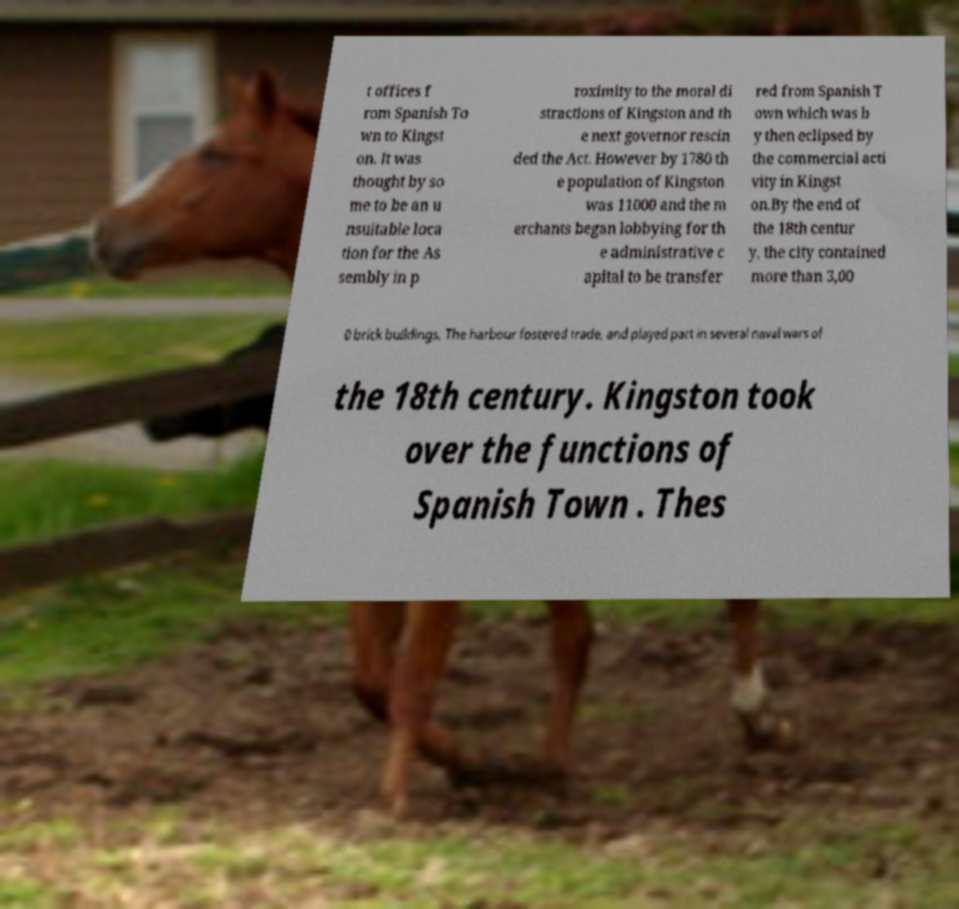For documentation purposes, I need the text within this image transcribed. Could you provide that? t offices f rom Spanish To wn to Kingst on. It was thought by so me to be an u nsuitable loca tion for the As sembly in p roximity to the moral di stractions of Kingston and th e next governor rescin ded the Act. However by 1780 th e population of Kingston was 11000 and the m erchants began lobbying for th e administrative c apital to be transfer red from Spanish T own which was b y then eclipsed by the commercial acti vity in Kingst on.By the end of the 18th centur y, the city contained more than 3,00 0 brick buildings. The harbour fostered trade, and played part in several naval wars of the 18th century. Kingston took over the functions of Spanish Town . Thes 